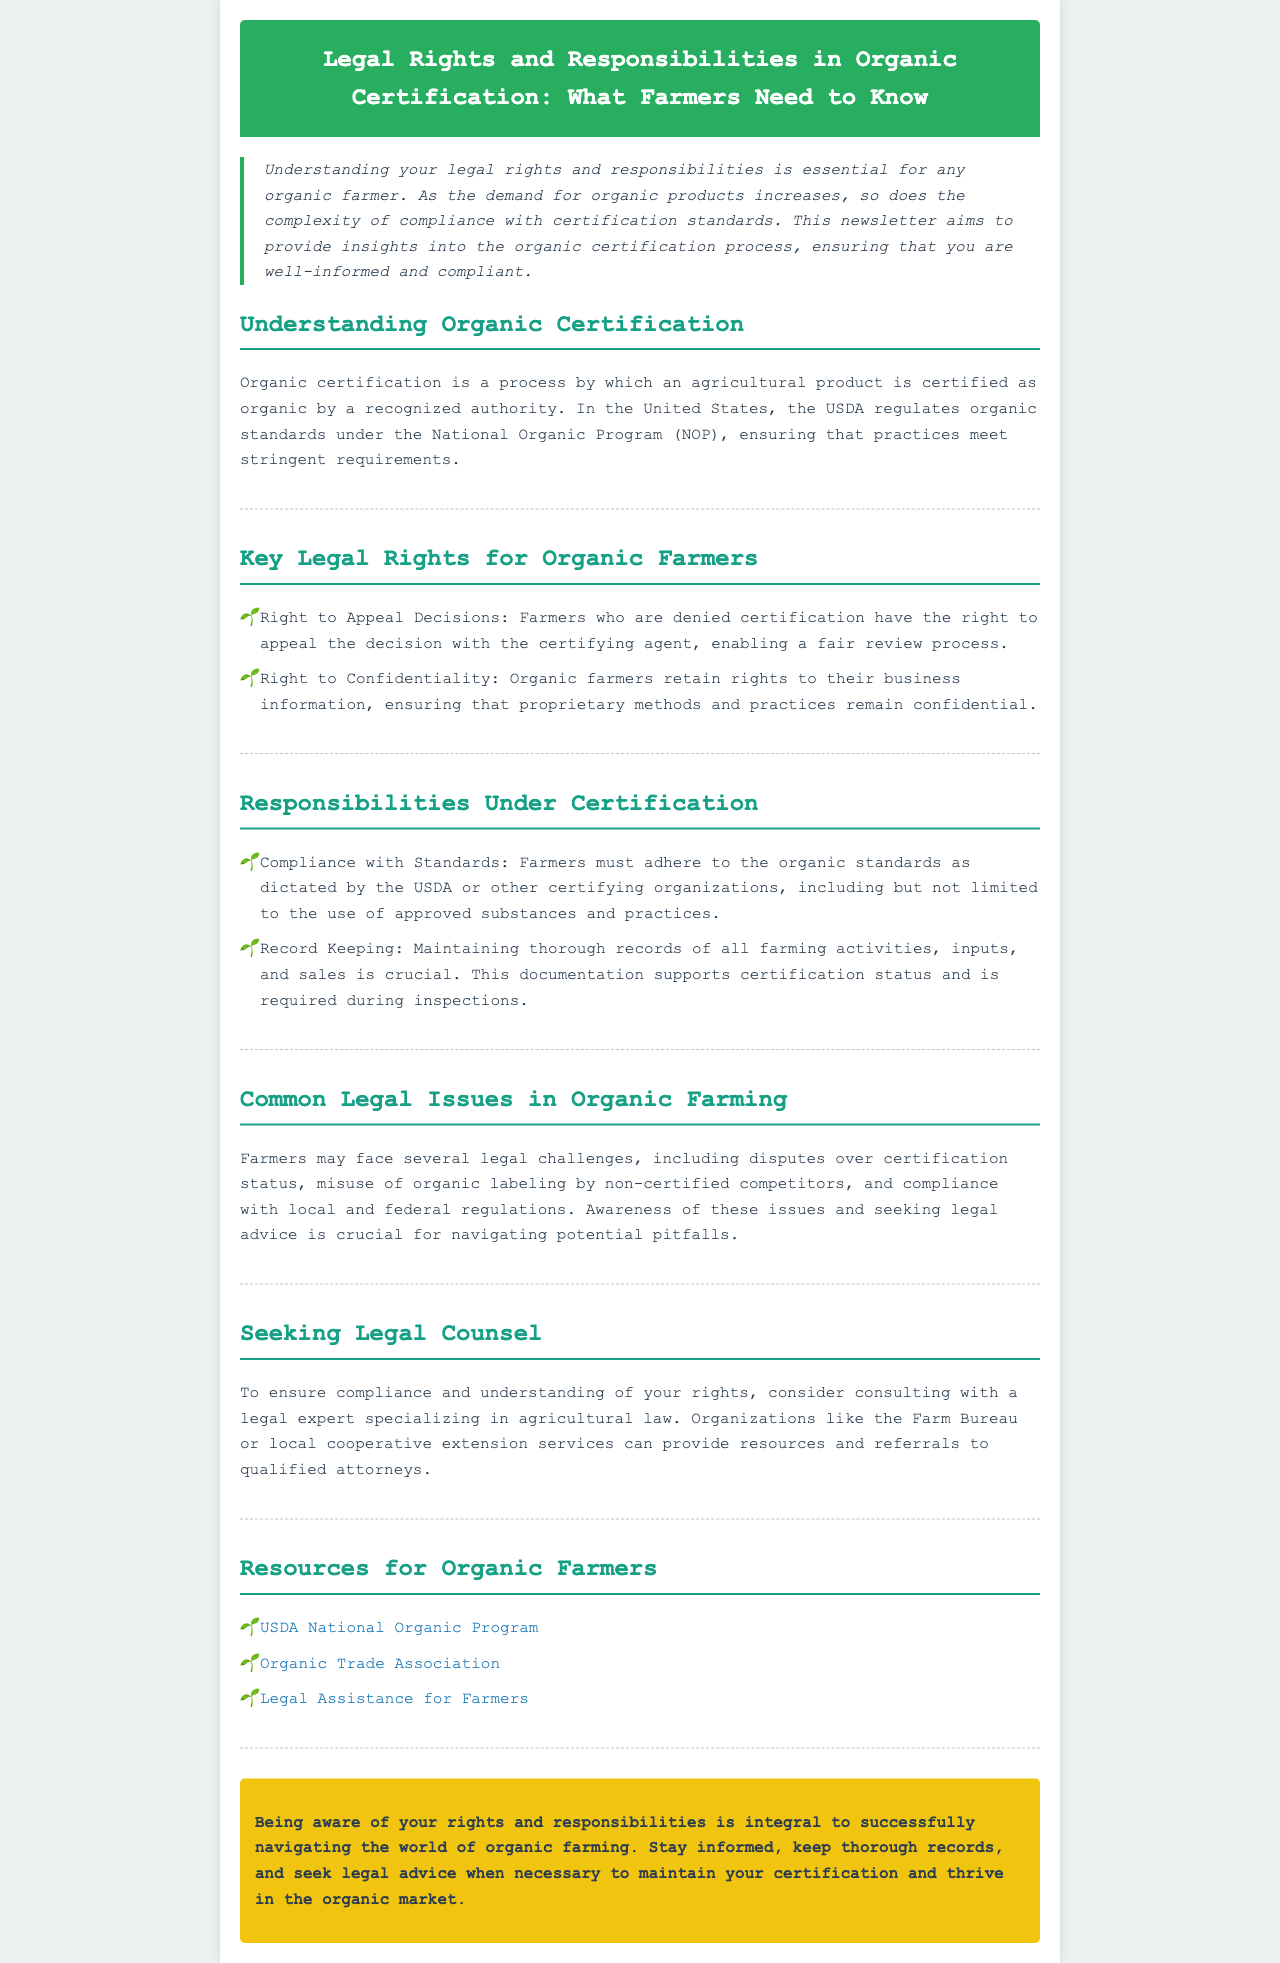what is the purpose of this newsletter? The newsletter aims to provide insights into the organic certification process, ensuring that you are well-informed and compliant.
Answer: to provide insights into the organic certification process which organization regulates organic standards in the United States? The document states that the USDA regulates organic standards under the National Organic Program.
Answer: USDA what right do farmers have if they are denied certification? The document specifies that farmers have the right to appeal the decision with the certifying agent.
Answer: to appeal the decision what must farmers maintain to support their certification status? The responsibilities section mentions that maintaining thorough records of all farming activities, inputs, and sales is crucial.
Answer: thorough records name one common legal issue faced by organic farmers. The document lists disputes over certification status as one of the common legal issues.
Answer: disputes over certification status who can farmers consult for legal advice? The document suggests consulting with a legal expert specializing in agricultural law.
Answer: legal expert specializing in agricultural law what is one resource provided for organic farmers? The document lists the USDA National Organic Program as a resource for organic farmers.
Answer: USDA National Organic Program what color is the header of the newsletter? The header is described as having a background color of #27ae60.
Answer: #27ae60 